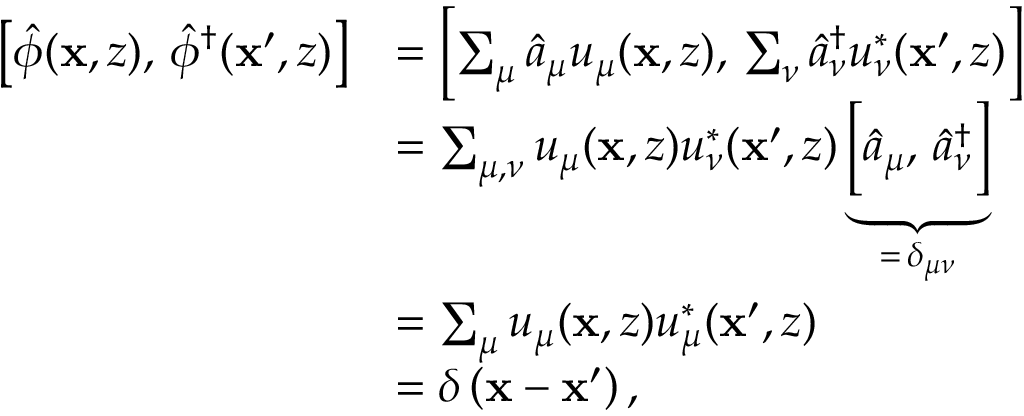Convert formula to latex. <formula><loc_0><loc_0><loc_500><loc_500>\begin{array} { r l } { \left [ \hat { \phi } ( x , z ) , \, \hat { \phi } ^ { \dagger } ( x ^ { \prime } , z ) \right ] } & { = \left [ \sum _ { \mu } \hat { a } _ { \mu } u _ { \mu } ( x , z ) , \, \sum _ { \nu } \hat { a } _ { \nu } ^ { \dagger } u _ { \nu } ^ { * } ( x ^ { \prime } , z ) \right ] } \\ & { = \sum _ { \mu , \nu } u _ { \mu } ( x , z ) u _ { \nu } ^ { * } ( x ^ { \prime } , z ) \underbrace { \left [ \hat { a } _ { \mu } , \, \hat { a } _ { \nu } ^ { \dagger } \right ] } _ { = \, \delta _ { \mu \nu } } } \\ & { = \sum _ { \mu } u _ { \mu } ( x , z ) u _ { \mu } ^ { * } ( x ^ { \prime } , z ) } \\ & { = \delta \left ( x - x ^ { \prime } \right ) , } \end{array}</formula> 